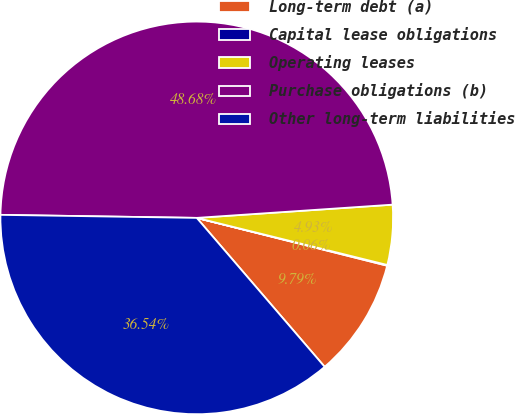<chart> <loc_0><loc_0><loc_500><loc_500><pie_chart><fcel>Long-term debt (a)<fcel>Capital lease obligations<fcel>Operating leases<fcel>Purchase obligations (b)<fcel>Other long-term liabilities<nl><fcel>9.79%<fcel>0.06%<fcel>4.93%<fcel>48.68%<fcel>36.54%<nl></chart> 